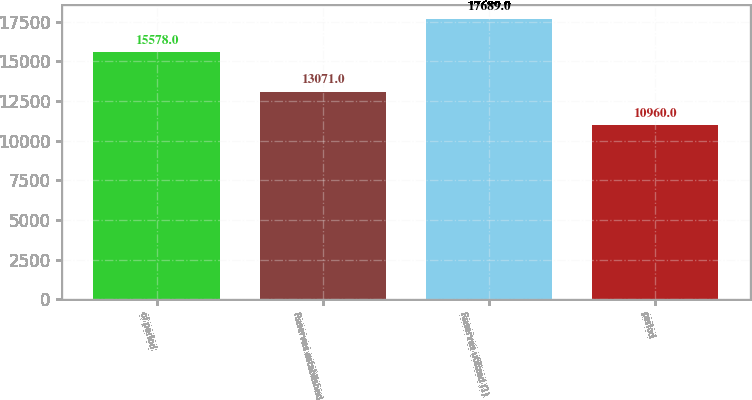Convert chart to OTSL. <chart><loc_0><loc_0><loc_500><loc_500><bar_chart><fcel>of period<fcel>Reserves established<fcel>Reserves utilized (1)<fcel>period<nl><fcel>15578<fcel>13071<fcel>17689<fcel>10960<nl></chart> 